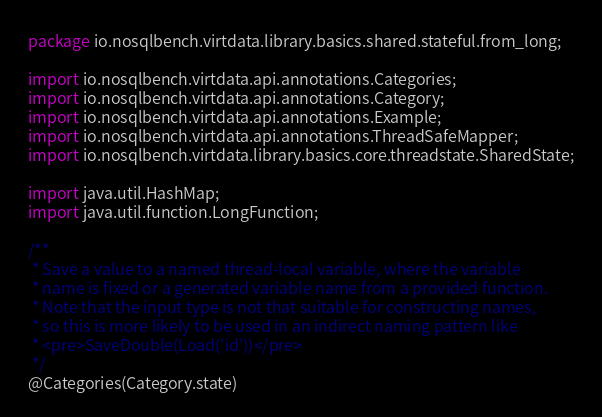<code> <loc_0><loc_0><loc_500><loc_500><_Java_>package io.nosqlbench.virtdata.library.basics.shared.stateful.from_long;

import io.nosqlbench.virtdata.api.annotations.Categories;
import io.nosqlbench.virtdata.api.annotations.Category;
import io.nosqlbench.virtdata.api.annotations.Example;
import io.nosqlbench.virtdata.api.annotations.ThreadSafeMapper;
import io.nosqlbench.virtdata.library.basics.core.threadstate.SharedState;

import java.util.HashMap;
import java.util.function.LongFunction;

/**
 * Save a value to a named thread-local variable, where the variable
 * name is fixed or a generated variable name from a provided function.
 * Note that the input type is not that suitable for constructing names,
 * so this is more likely to be used in an indirect naming pattern like
 * <pre>SaveDouble(Load('id'))</pre>
 */
@Categories(Category.state)</code> 